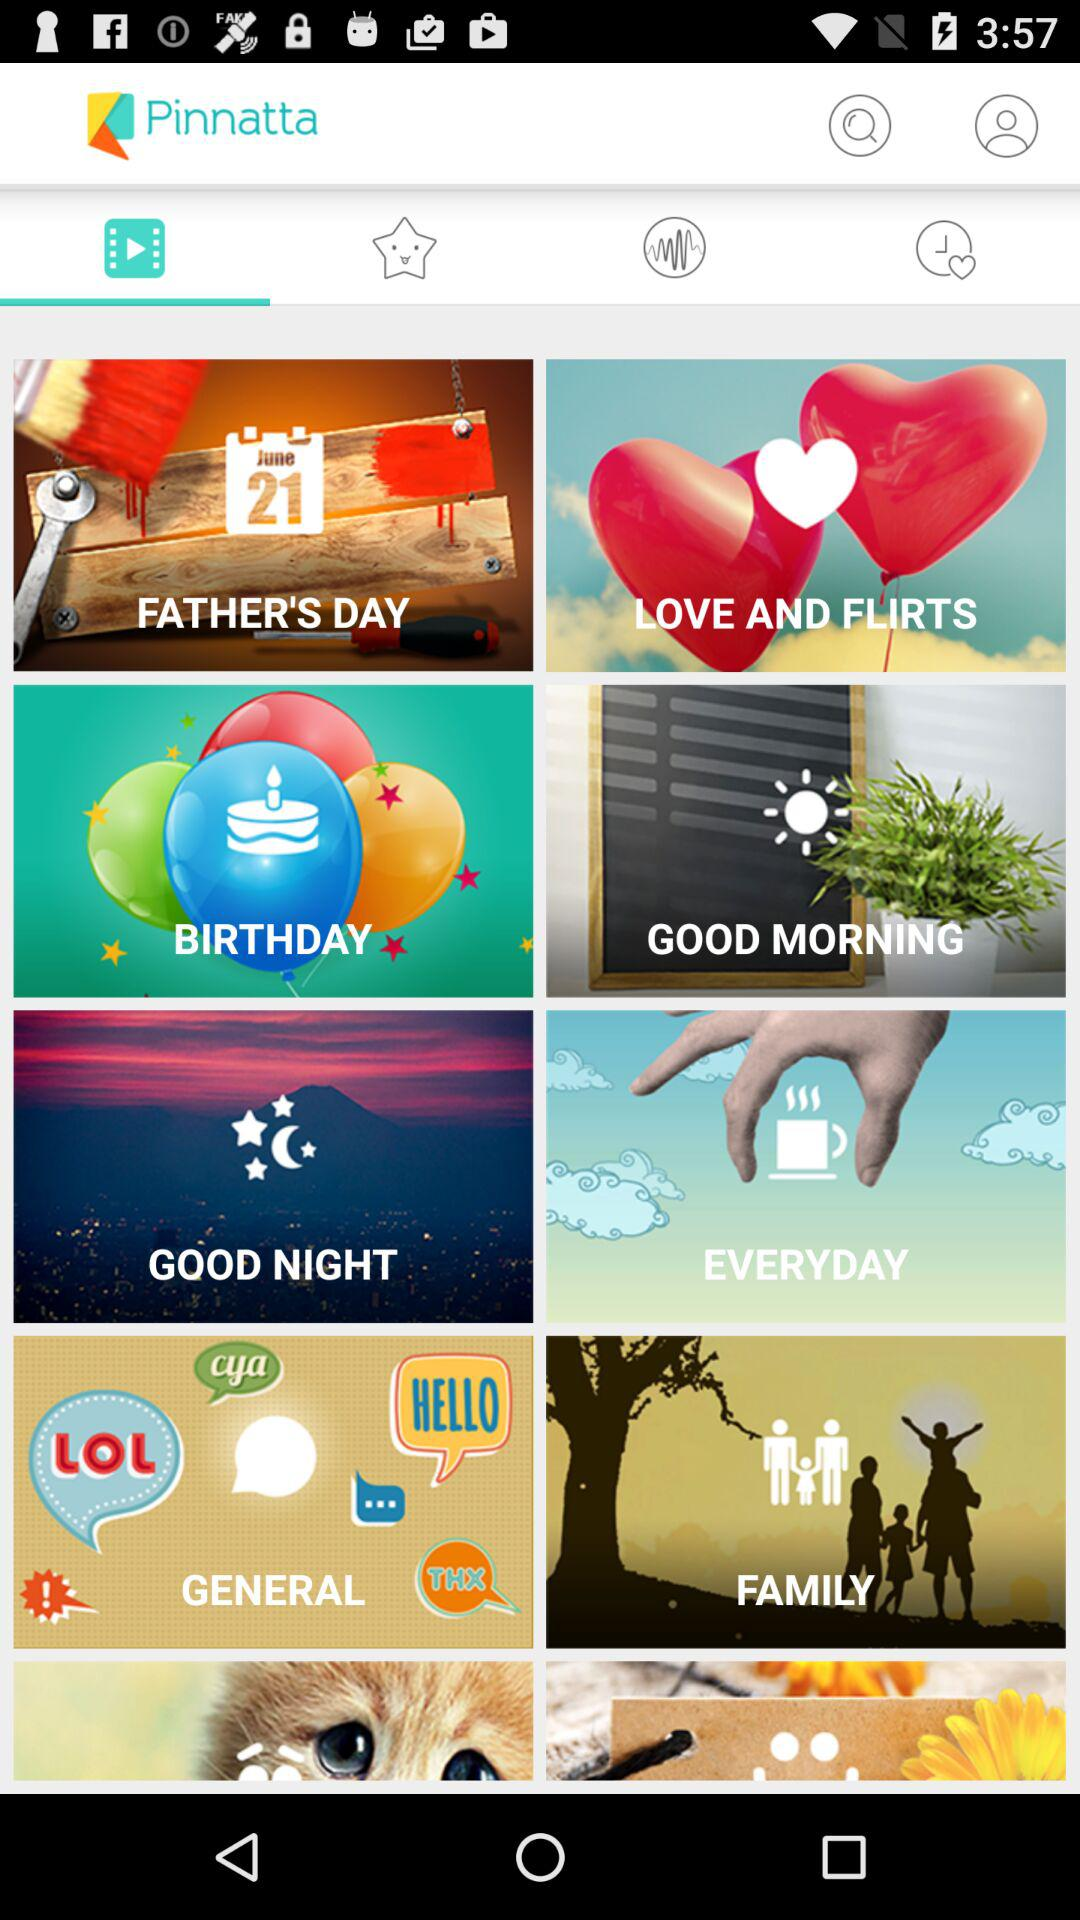Which tab has been selected? The selected tab is "Video". 